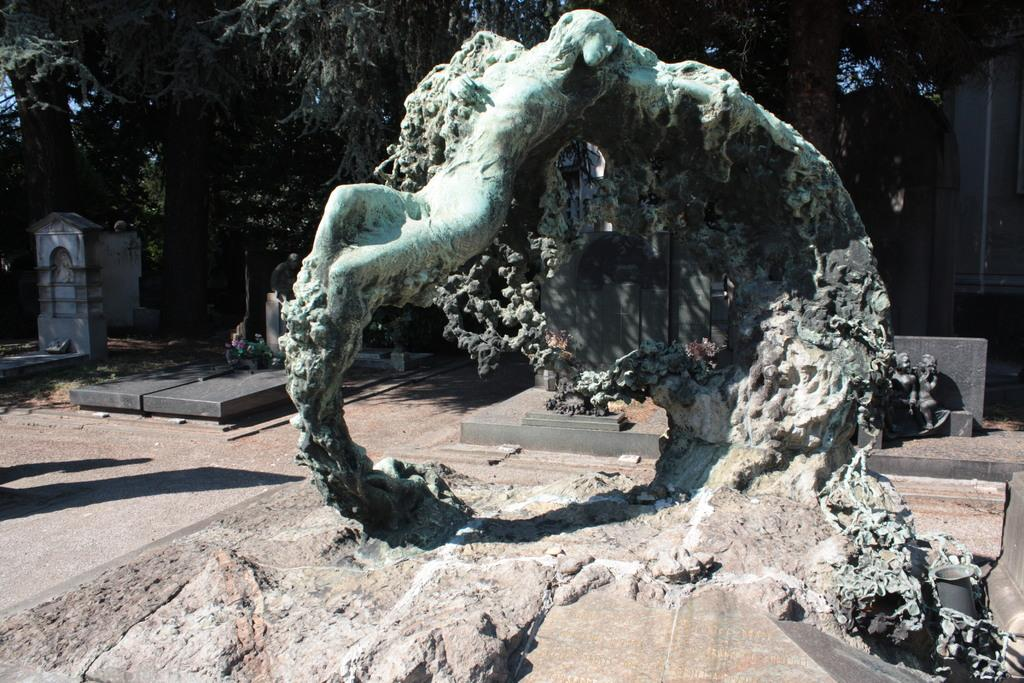Where is the setting of the image? The image is set inside a graveyard. What can be seen in the graveyard? There are many graves in the graveyard. What type of vegetation is present in the graveyard? There are trees surrounding the graves. What is the main feature in the front of the image? There is a sculpture in the front of the image. What type of cable is used to connect the graves in the image? There is no cable connecting the graves in the image; they are separate entities. 